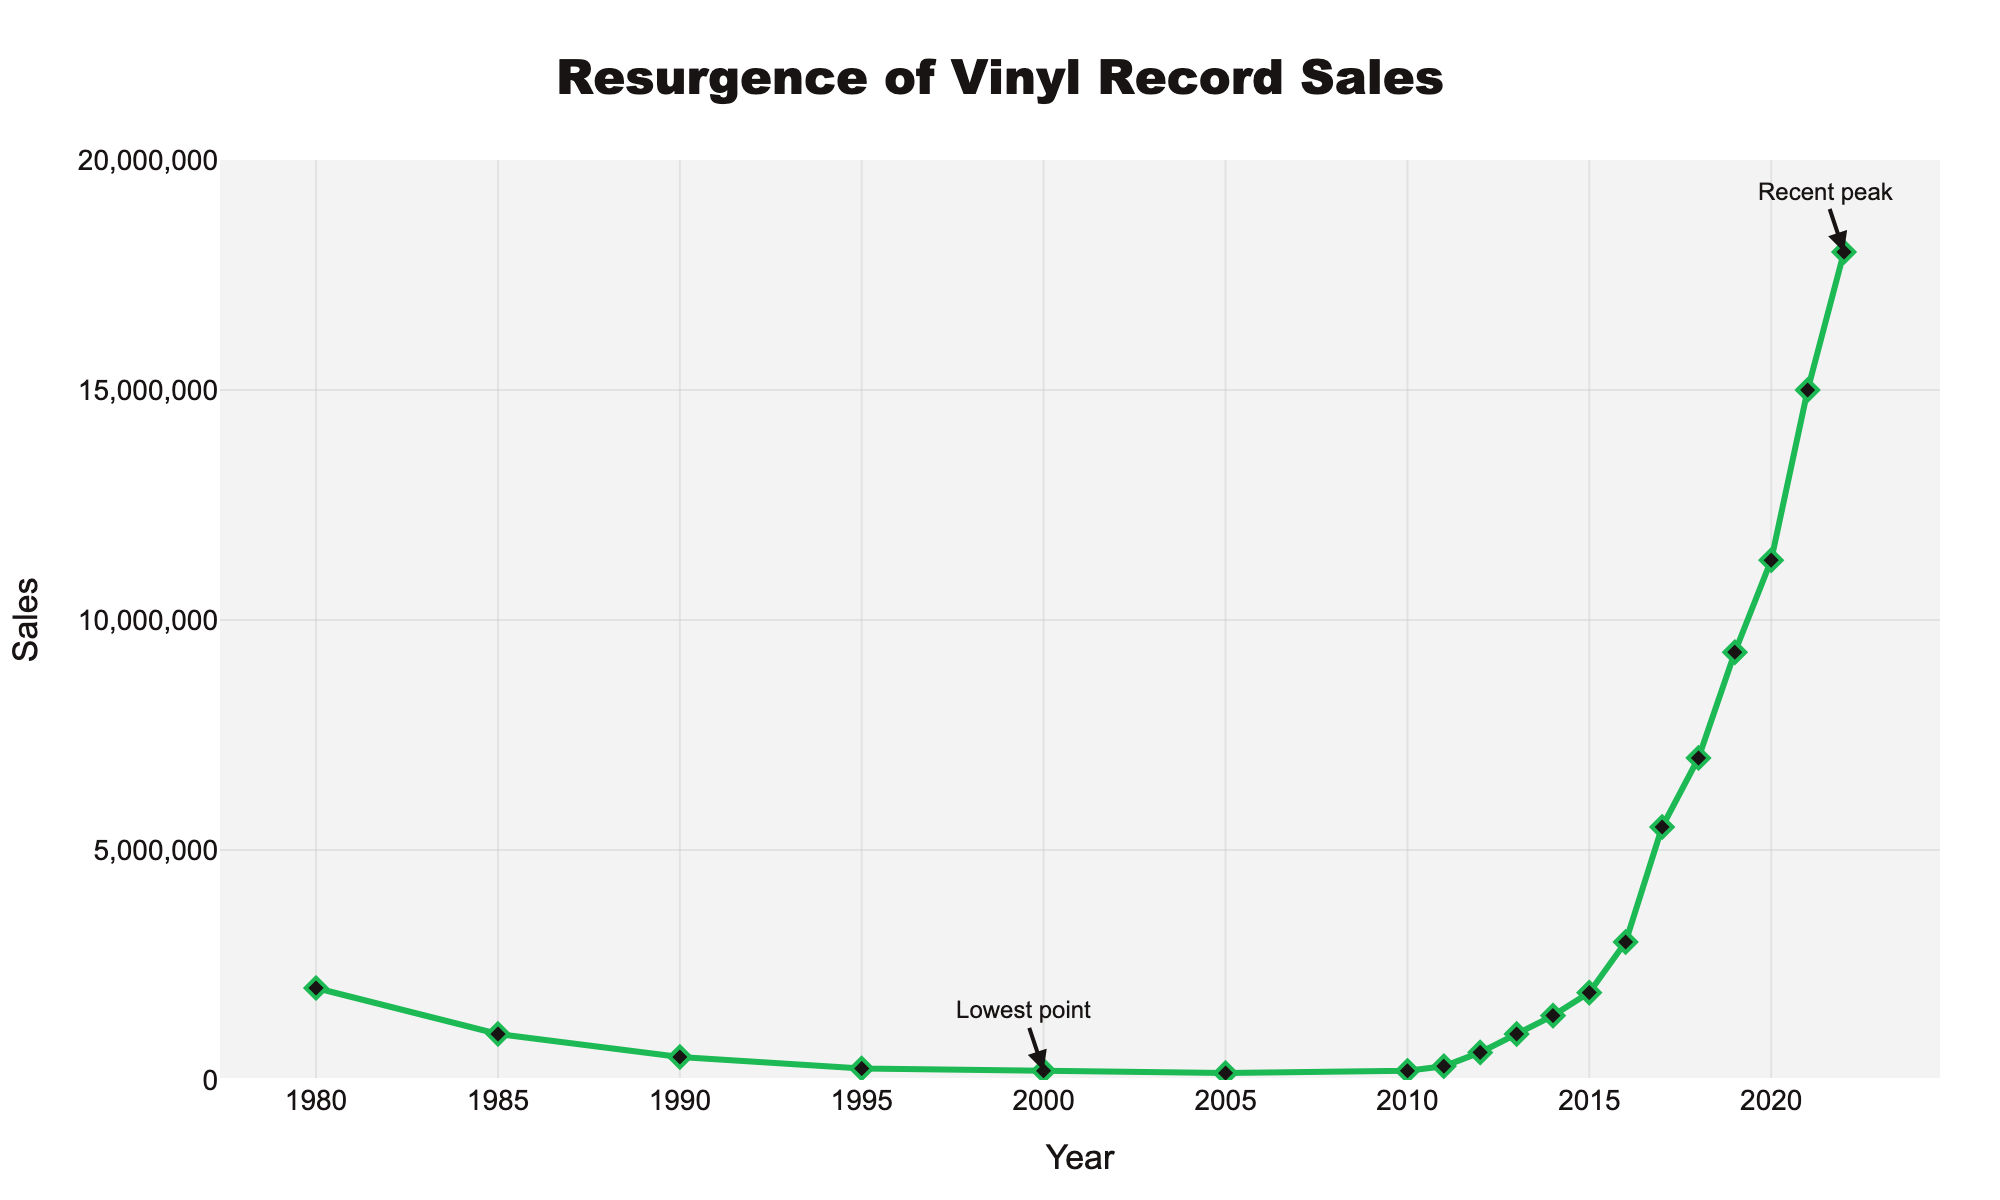What is the title of the figure? The title is typically located at the top of the figure and reads "Resurgence of Vinyl Record Sales".
Answer: Resurgence of Vinyl Record Sales What is the lowest point of vinyl record sales according to the figure? The figure has an annotation pointing to the lowest point, which is approximately in the year 2000, with sales of 200,000 units.
Answer: 200,000 units What year is marked as the "Recent peak" in vinyl record sales? The figure has an annotation pointing to the recent peak, which is in the year 2022, with sales of 18,000,000 units.
Answer: 2022 How did vinyl record sales change from the year 2000 to 2022? To find this, we look at the sales figures for 2000 and 2022. The sales in 2000 were 200,000 units and in 2022 were 18,000,000 units. We need to subtract the former from the latter to find the change: 18,000,000 - 200,000 = 17,800,000.
Answer: Increased by 17,800,000 units In which decade did vinyl record sales begin to decline according to the figure? By observing the sales trend in the figure, we can see that the decline starts after 1980, so the decade during which the decline began is the 1980s.
Answer: 1980s What is the sales figure for vinyl records in 2015? We can find the specific sales figure by locating the point for the year 2015 on the x-axis and reading the corresponding y-axis value, which is 1,900,000 units.
Answer: 1,900,000 units Compare the sales in 1980 and 2020. By what percentage did they change? First, the sales in 1980 were 2,000,000 units and in 2020 were 11,300,000 units. The change is 11,300,000 - 2,000,000 = 9,300,000 units. To find the percentage change: (9,300,000 / 2,000,000) * 100 ≈ 465%.
Answer: Increased by 465% What was the approximate annual growth rate in vinyl record sales from 2010 to 2022? First, find the sales in 2010 (200,000 units) and 2022 (18,000,000 units). The duration is 2022 - 2010 = 12 years. The annual growth rate can be approximated using the formula for Compound Annual Growth Rate (CAGR): \( CAGR = \left( \frac{Ending\ Value}{Beginning\ Value} \right)^{\frac{1}{n}} - 1 \). Substituting values, \( CAGR = \left( \frac{18000000}{200000} \right)^{\frac{1}{12}} - 1 ≈ 0.38 \). Converting to percentage: \( 0.38 * 100 \) ≈ 38%.
Answer: Approximately 38% From 2013 to 2017, how did vinyl record sales change? By looking at the sales data for 2013 (1,000,000 units) and 2017 (5,500,000 units), we find the net change: 5,500,000 - 1,000,000 = 4,500,000 units.
Answer: Increased by 4,500,000 units What general trend do you observe in vinyl record sales from 2005 to 2022? Observing the sales data points from 2005 onward, it is evident that there is a continuous increase in vinyl record sales, indicating a resurgence in popularity.
Answer: Continuous increase 